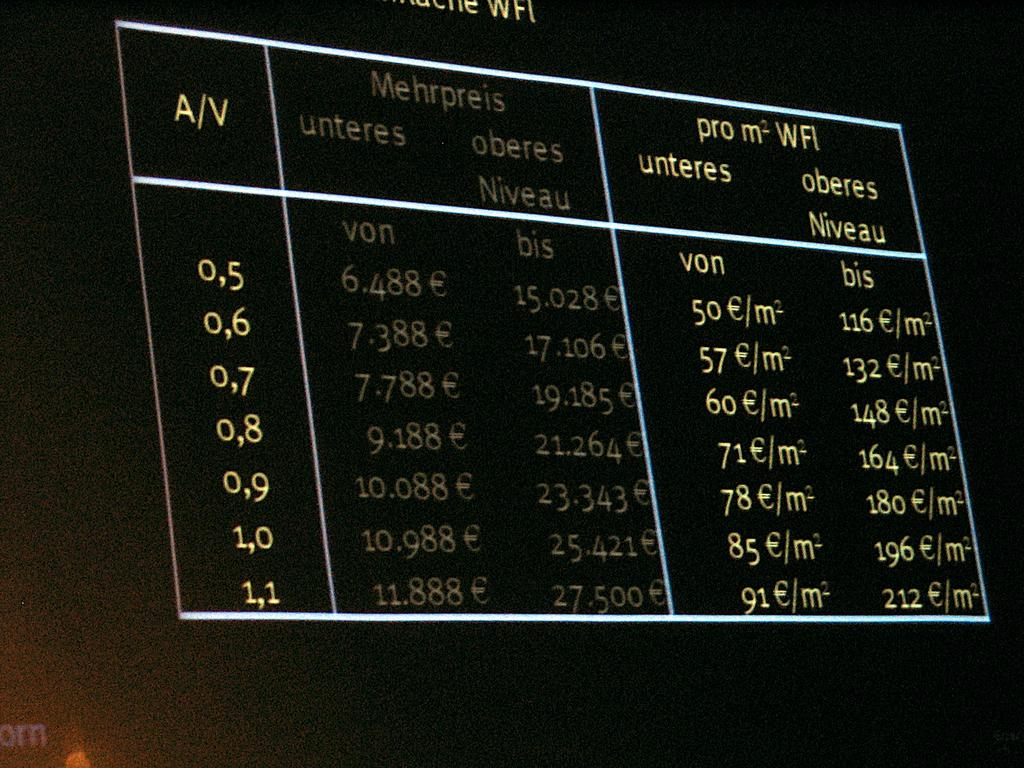<image>
Offer a succinct explanation of the picture presented. black screen with numbers in columns for A/V, Mehrpreis, and pro m2WFI 